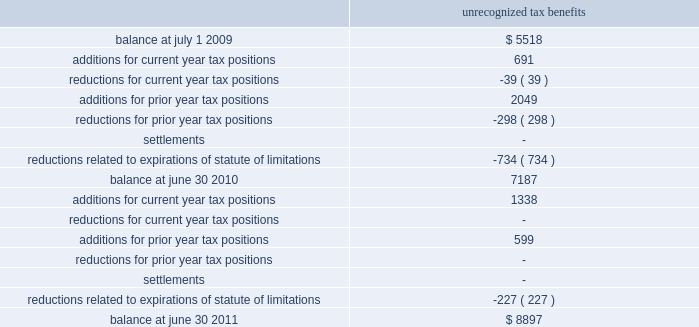Fy 11 | 53 the company paid income taxes of $ 60515 , $ 42116 , and $ 62965 in 2011 , 2010 , and 2009 , respectively .
At june 30 , 2010 , the company had $ 7187 of unrecognized tax benefits .
At june 30 , 2011 , the company had $ 8897 of unrecognized tax benefits , of which , $ 6655 , if recognized , would affect our effective tax rate .
We had accrued interest and penalties of $ 1030 and $ 890 related to uncertain tax positions at june 30 , 2011 and 2010 , respectively .
A reconciliation of the unrecognized tax benefits for the years ended june 30 , 2011 and 2010 follows : unrecognized tax benefits .
During the fiscal year ended june 30 , 2010 , the internal revenue service commenced an examination of the company 2019s u.s .
Federal income tax returns for fiscal years ended june 2008 through 2009 that is anticipated to be completed by the end of calendar year 2011 .
At this time , it is anticipated that the examination will not result in a material change to the company 2019s financial position .
The u.s .
Federal and state income tax returns for june 30 , 2008 and all subsequent years still remain subject to examination as of june 30 , 2011 under statute of limitations rules .
We anticipate potential changes resulting from our irs examination and expiration of statutes of limitations could reduce the unrecognized tax benefits balance by $ 3000 - $ 4000 within twelve months of june 30 , 2011 .
Note 8 : industry and supplier concentrations the company sells its products to banks , credit unions , and financial institutions throughout the united states and generally does not require collateral .
All billings to customers are due 30 days from date of billing .
Reserves ( which are insignificant at june 30 , 2011 , 2010 and 2009 ) are maintained for potential credit losses .
In addition , the company purchases most of its computer hardware and related maintenance for resale in relation to installation of jha software systems from two suppliers .
There are a limited number of hardware suppliers for these required items .
If these relationships were terminated , it could have a significant negative impact on the future operations of the company .
Note 9 : stock based compensation plans our pre-tax operating income for the years ended june 30 , 2011 , 2010 and 2009 includes $ 4723 , $ 3251 and $ 2272 of stock-based compensation costs , respectively .
Total compensation cost for the years ended june 30 , 2011 , 2010 and 2009 includes $ 4209 , $ 2347 , and $ 1620 relating to the restricted stock plan , respectively. .
During 2011 , what were the net additions for unrecognized tax benefits for all years? 
Computations: (1338 + 599)
Answer: 1937.0. 